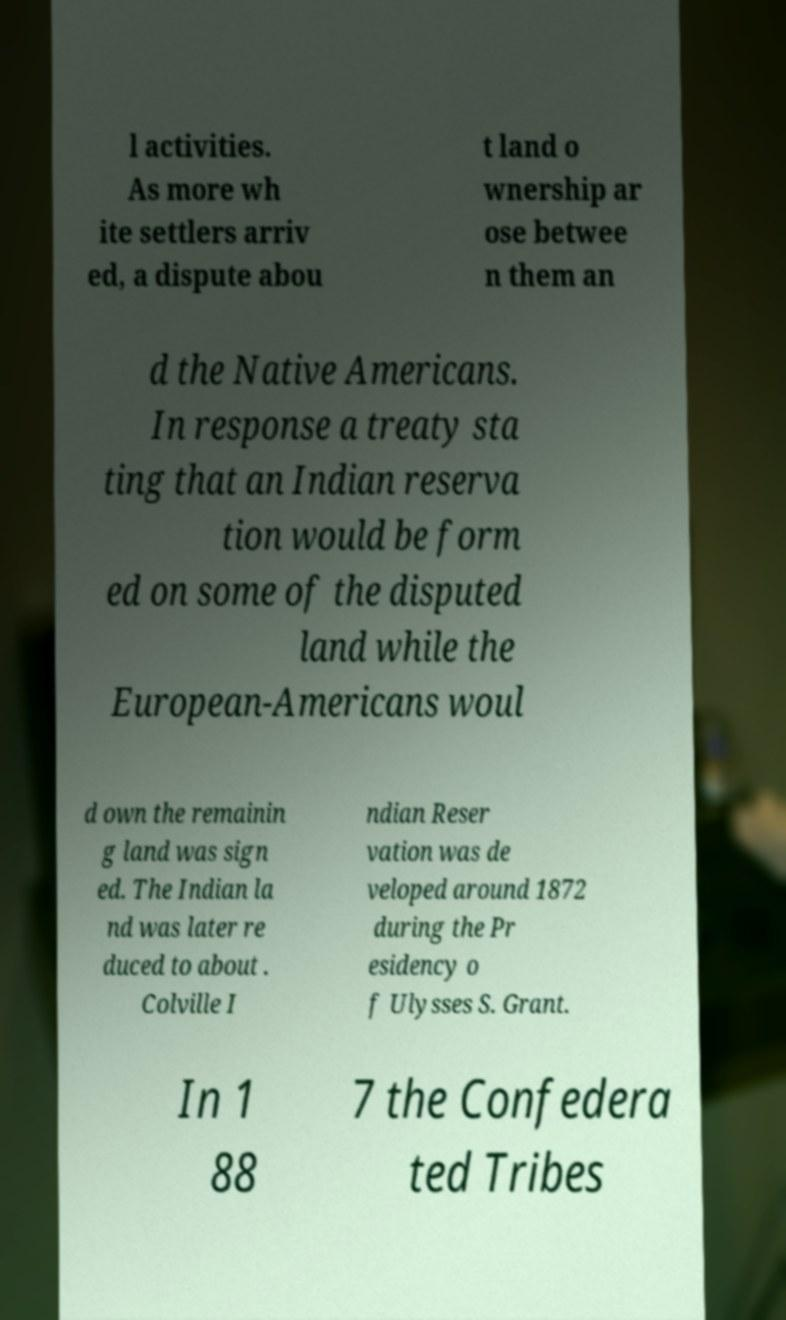Could you assist in decoding the text presented in this image and type it out clearly? l activities. As more wh ite settlers arriv ed, a dispute abou t land o wnership ar ose betwee n them an d the Native Americans. In response a treaty sta ting that an Indian reserva tion would be form ed on some of the disputed land while the European-Americans woul d own the remainin g land was sign ed. The Indian la nd was later re duced to about . Colville I ndian Reser vation was de veloped around 1872 during the Pr esidency o f Ulysses S. Grant. In 1 88 7 the Confedera ted Tribes 